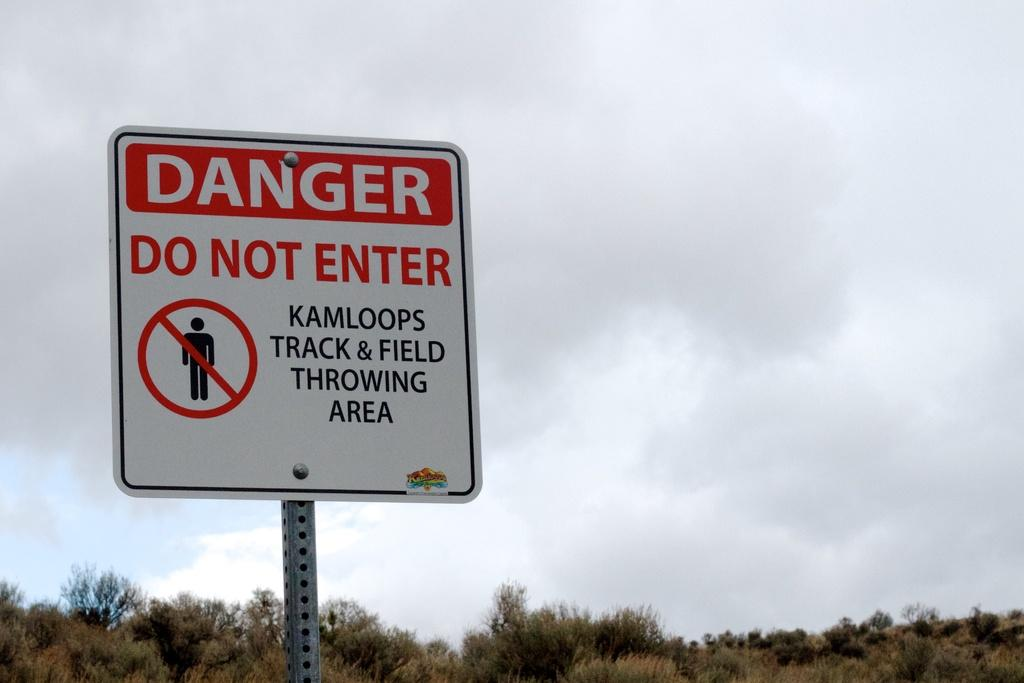What is located in the foreground of the image? There is a board in the foreground of the image. What can be seen on the board? There is text on the board. What type of vegetation is present at the bottom of the image? Trees are present at the bottom of the image. What is visible in the background of the image? The sky is visible in the background of the image. How would you describe the sky in the image? The sky is cloudy in the image. What is the weight of the quince hanging from the tree in the image? There is no quince present in the image, so it is not possible to determine its weight. 